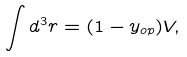<formula> <loc_0><loc_0><loc_500><loc_500>\int { d ^ { 3 } r } = ( 1 - y _ { o p } ) V ,</formula> 